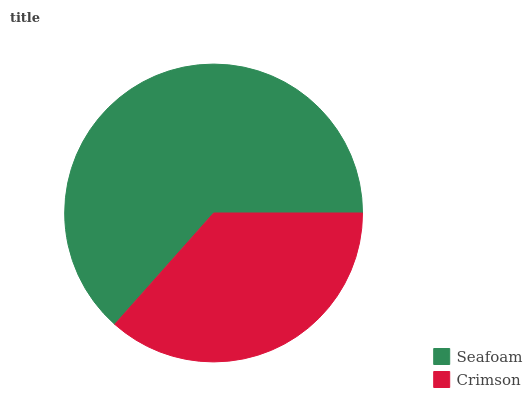Is Crimson the minimum?
Answer yes or no. Yes. Is Seafoam the maximum?
Answer yes or no. Yes. Is Crimson the maximum?
Answer yes or no. No. Is Seafoam greater than Crimson?
Answer yes or no. Yes. Is Crimson less than Seafoam?
Answer yes or no. Yes. Is Crimson greater than Seafoam?
Answer yes or no. No. Is Seafoam less than Crimson?
Answer yes or no. No. Is Seafoam the high median?
Answer yes or no. Yes. Is Crimson the low median?
Answer yes or no. Yes. Is Crimson the high median?
Answer yes or no. No. Is Seafoam the low median?
Answer yes or no. No. 